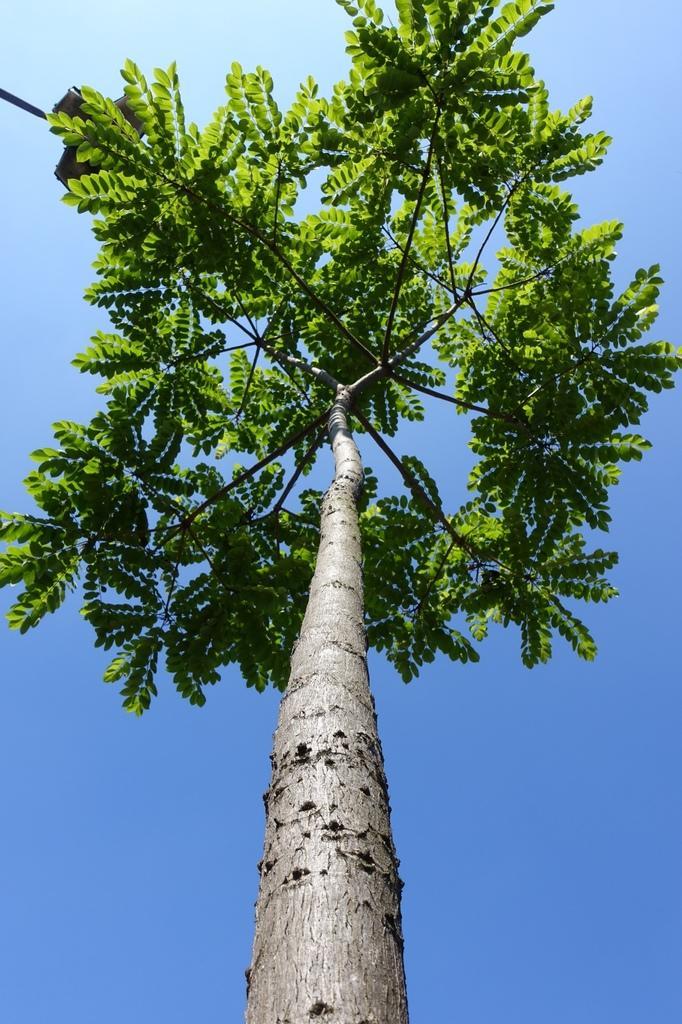How would you summarize this image in a sentence or two? In this image in the center there is one tree, and in the background there is sky. 